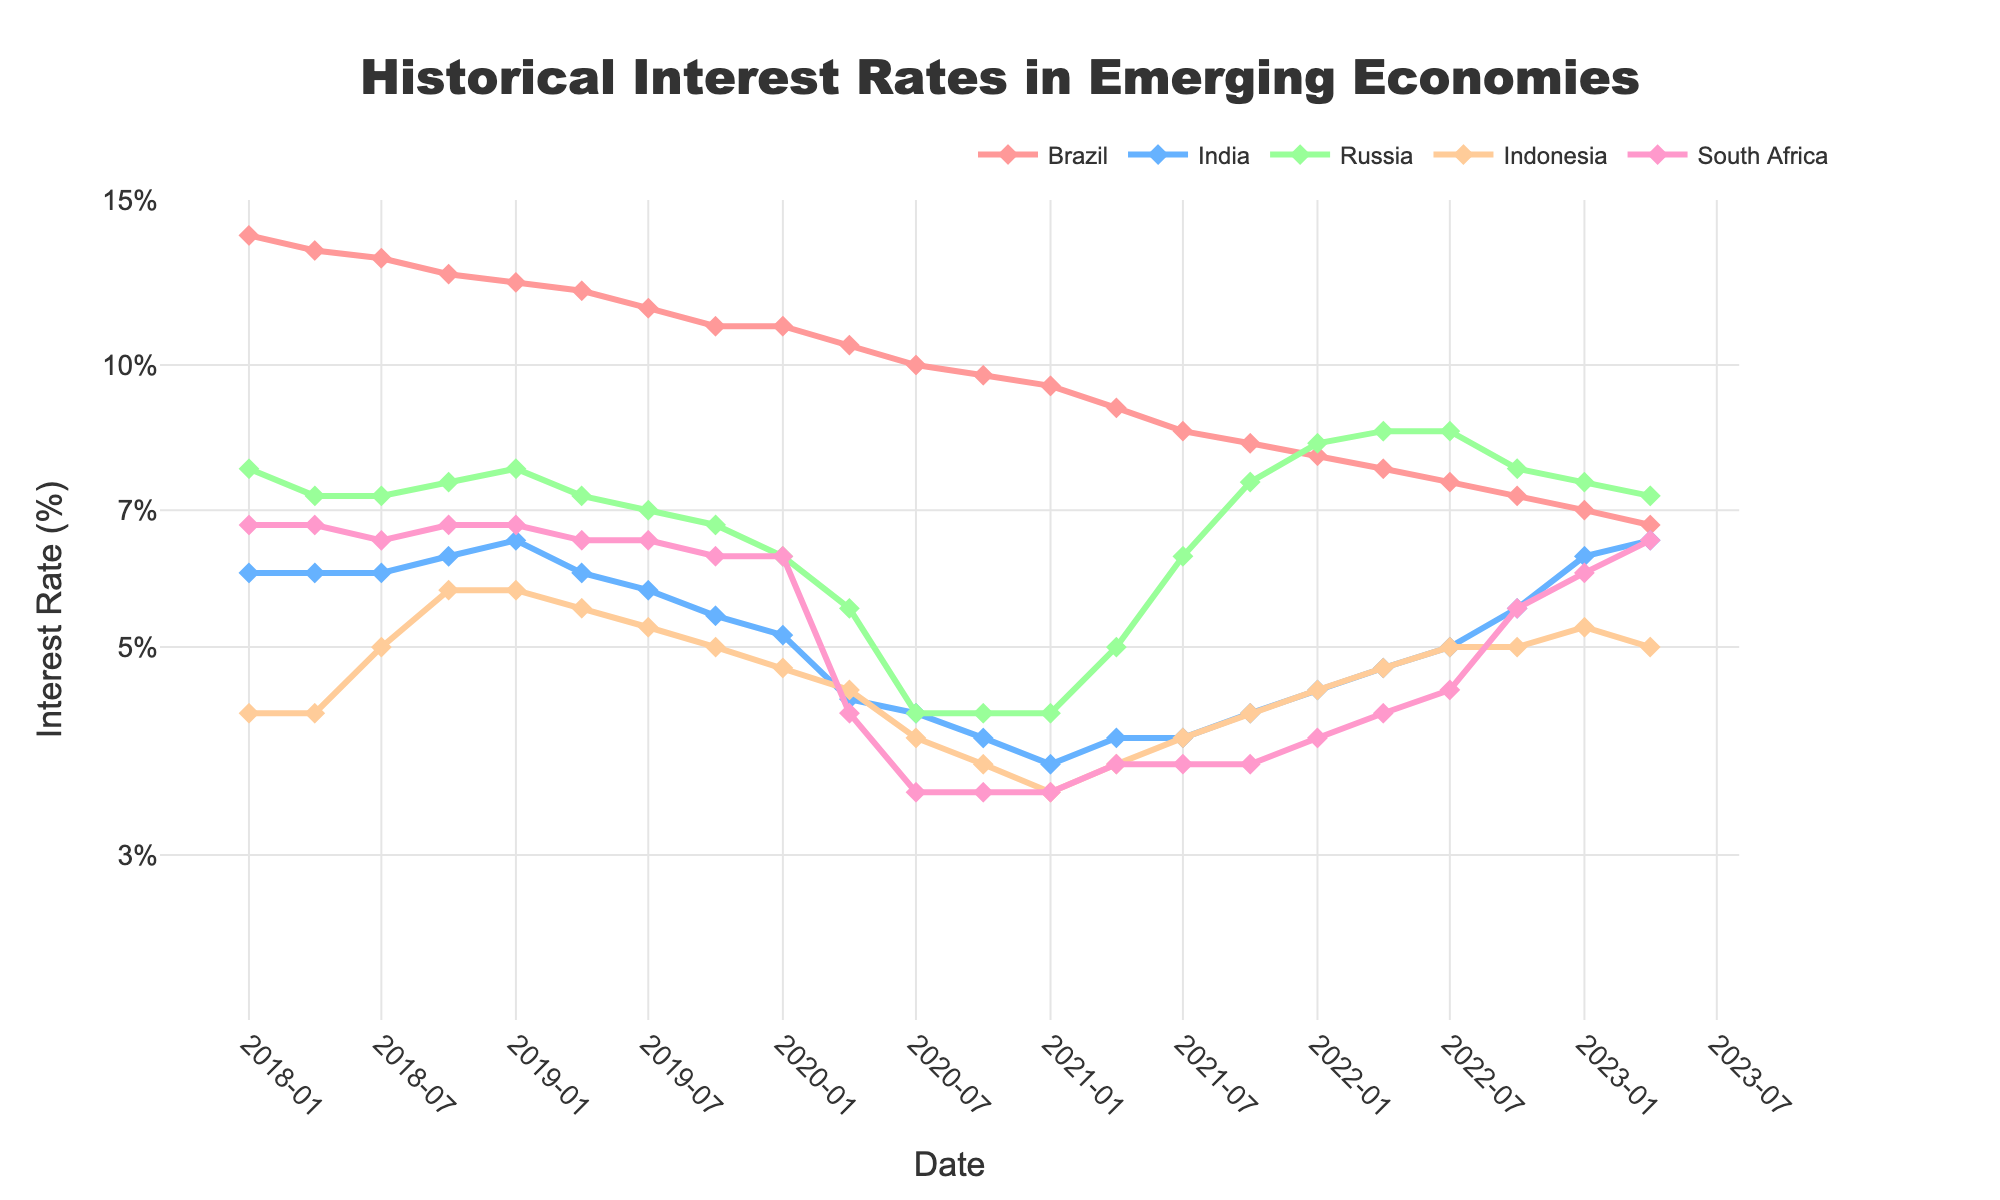What's the title of the plot? The title of the plot is located at the top and is meant to provide a summary of what the plot shows.
Answer: Historical Interest Rates in Emerging Economies Which country had the highest interest rate in the first quarter of 2018? By observing the lines and markers corresponding to January 2018 on the plot, we can identify which country has the highest interest rate.
Answer: Brazil What trend can be observed in India's interest rates between 2021 and 2023? Look at the line representing India from 2021 to 2023. Notice the direction of the line, whether it is increasing, decreasing, or staying constant.
Answer: Increasing How does the interest rate of South Africa in 2020-01 compare to that in 2020-04? Find the markers for South Africa in 2020-01 and 2020-04 and compare their positions on the y-axis (interest rate).
Answer: Slightly lower Which country shows a notable decrease in interest rates during 2020? By looking at the steepness and direction of each line during 2020, you can identify the country with a significant drop.
Answer: Russia What is the approximate interest rate range for Brazil over the entire time span? Observe the highest and lowest points of the line representing Brazil to estimate the range of interest rates.
Answer: 6.75% to 13.75% Can you identify any period where Indonesia's interest rate remained constant? Check for sections of Indonesia's line that have no slope (flat segments), indicating no change in interest rates over the period.
Answer: 2018-01 to 2018-04 Which country experienced the highest peak in interest rates within the data range? By observing the maximum points on each of the country's lines, we identify the one with the highest peak.
Answer: Brazil How does the trend in Russia's interest rates compare to that of Indonesia from 2019-2023? Compare the lines representing Russia and Indonesia from 2019 to 2023, noting whether they both increase, decrease, or have differing trends.
Answer: Russia generally declines, then stabilizes; Indonesia fluctuates slightly Between 2020-01 and 2021-01, which country reduced its interest rates the most? Identify the difference in interest rates for each country between 2020-01 and 2021-01, comparing the magnitude of the change.
Answer: South Africa 